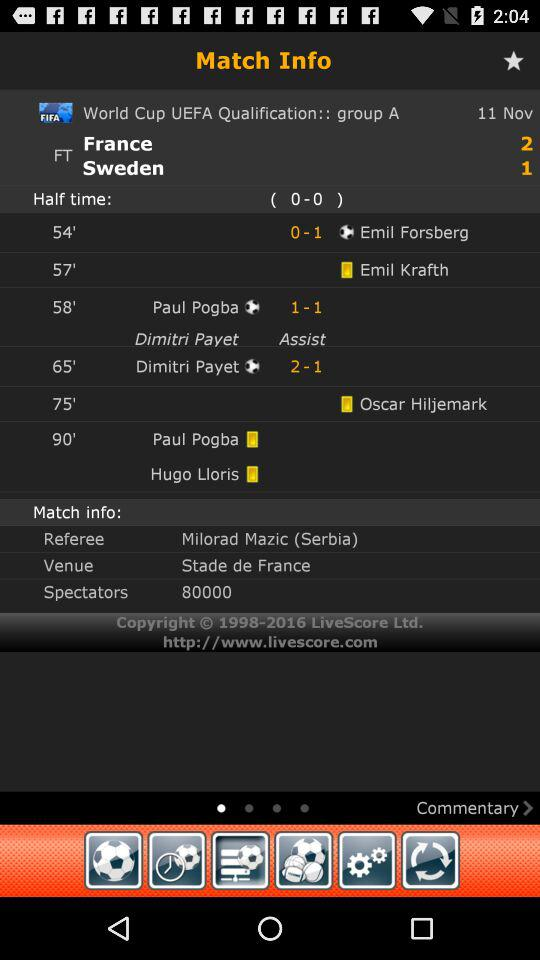What is the date of the ongoing match between France and Sweden? The date is November 11. 